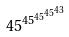<formula> <loc_0><loc_0><loc_500><loc_500>4 5 ^ { 4 5 ^ { 4 5 ^ { 4 5 ^ { 4 3 } } } }</formula> 